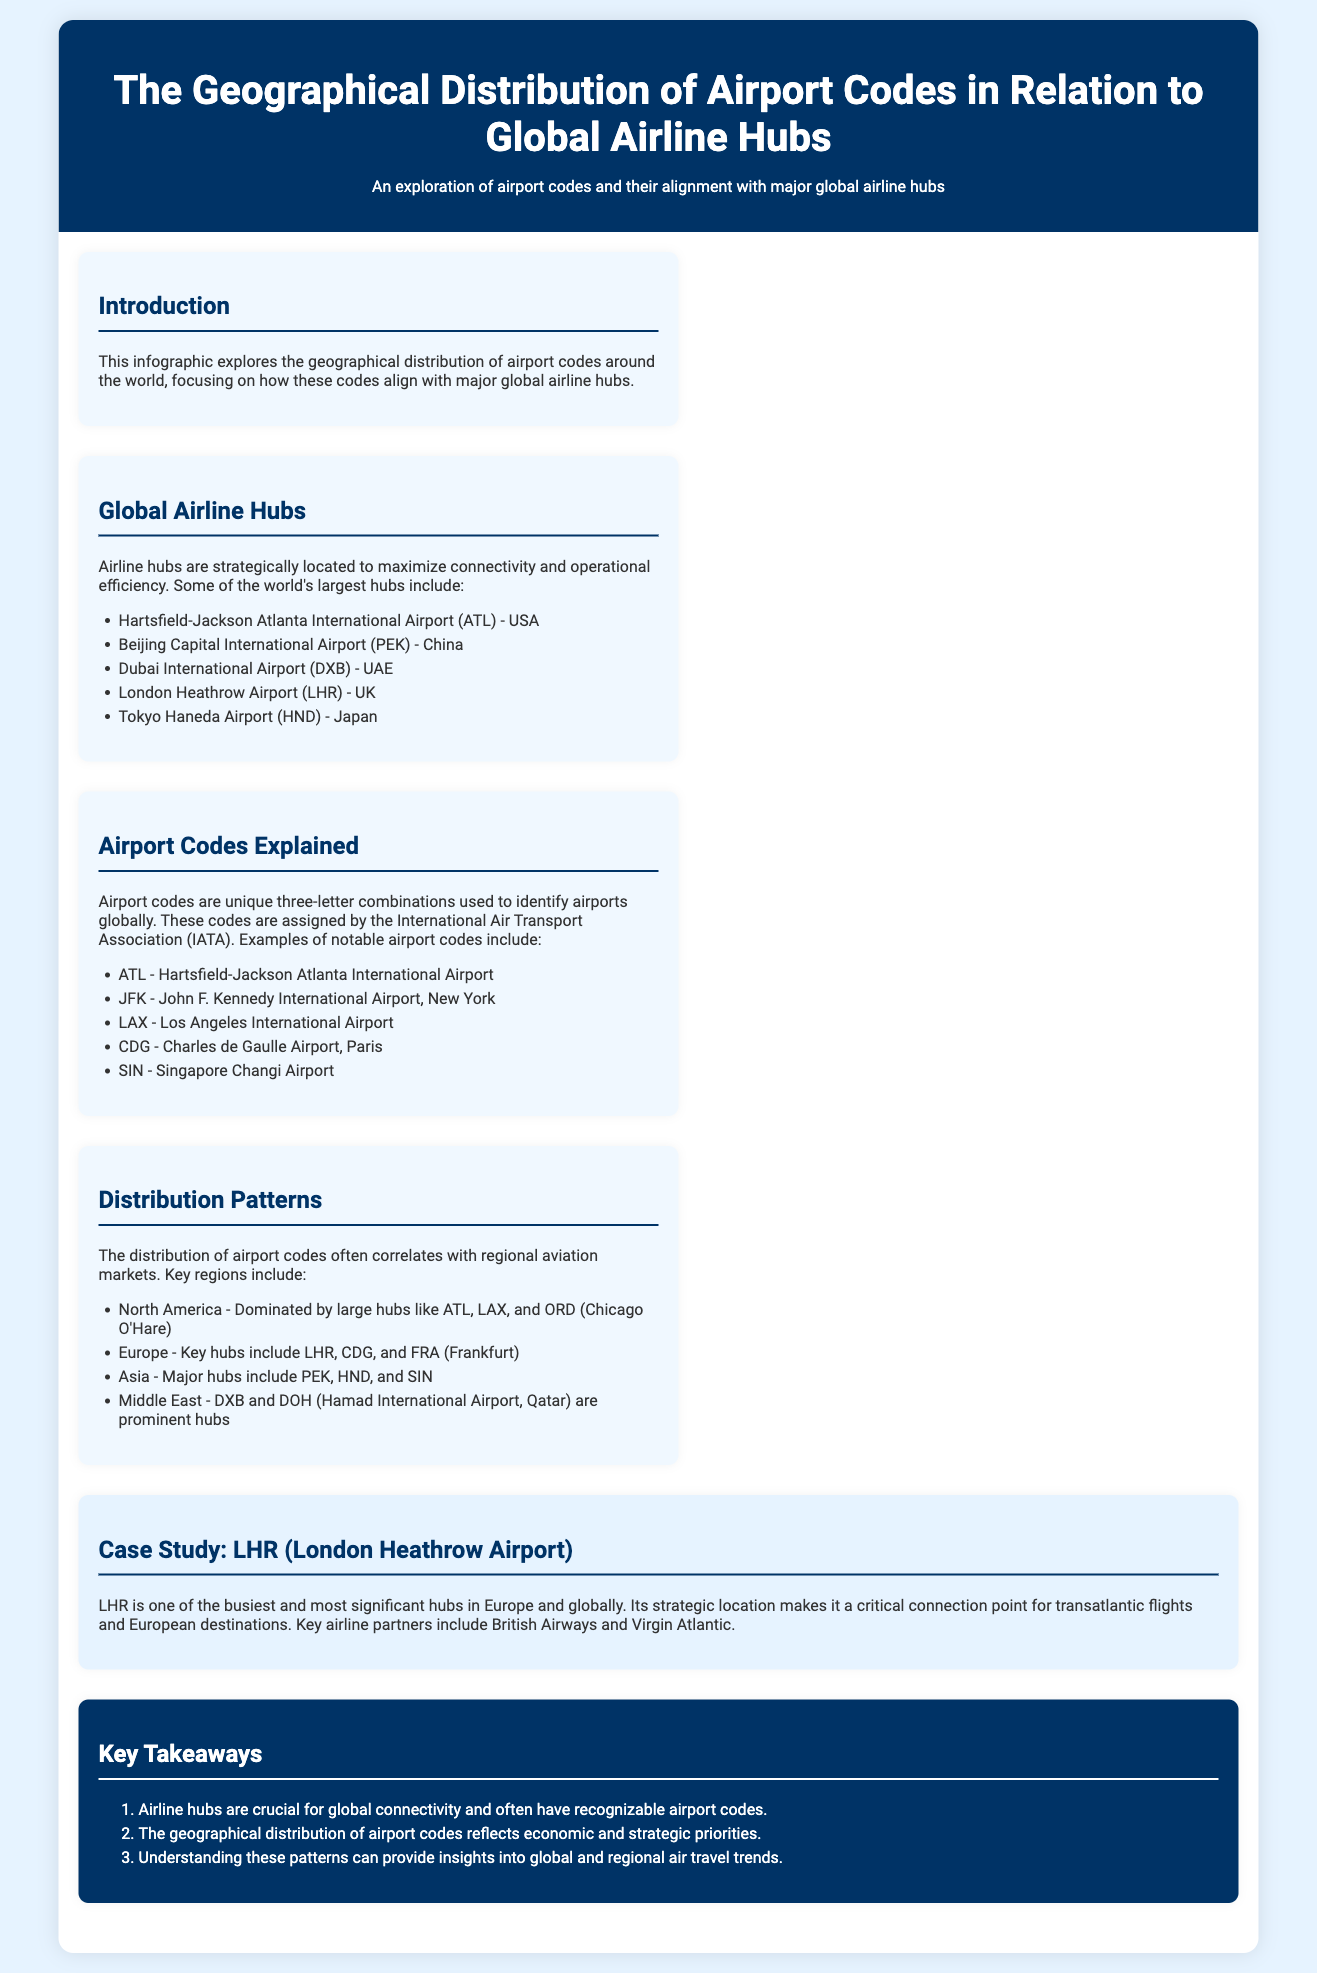What is the title of the infographic? The title of the infographic is found at the top of the document and introduces the main topic of the content.
Answer: The Geographical Distribution of Airport Codes in Relation to Global Airline Hubs Which airport is represented by the code ATL? ATL is mentioned in the list of notable airport codes and is identified with its full name in the document.
Answer: Hartsfield-Jackson Atlanta International Airport How many key airline hubs are listed in the document? The document lists five key airline hubs under the "Global Airline Hubs" section.
Answer: 5 What is a prominent airport code in Asia? The document provides examples of airport codes and indicates which regions they are associated with, specifically naming a major hub in Asia.
Answer: PEK Which airport code corresponds to London Heathrow? The document explicitly states the airport code associated with London Heathrow Airport under the "Airport Codes Explained" section.
Answer: LHR What does LHR stand for? LHR is explained in connection with its full name in the document, identifying a significant global hub.
Answer: London Heathrow Airport What region is dominated by large hubs like ATL and LAX? The document outlines distribution patterns and mentions specific regions that dominate certain airport codes.
Answer: North America Which two airlines are mentioned as key partners of LHR? The document includes specific information in the case study section about airline partners associated with London Heathrow Airport.
Answer: British Airways and Virgin Atlantic What insight do the key takeaways provide regarding airport codes? The key takeaways summarize critical understandings about airport codes and their effects on global connectivity.
Answer: Connectivity 